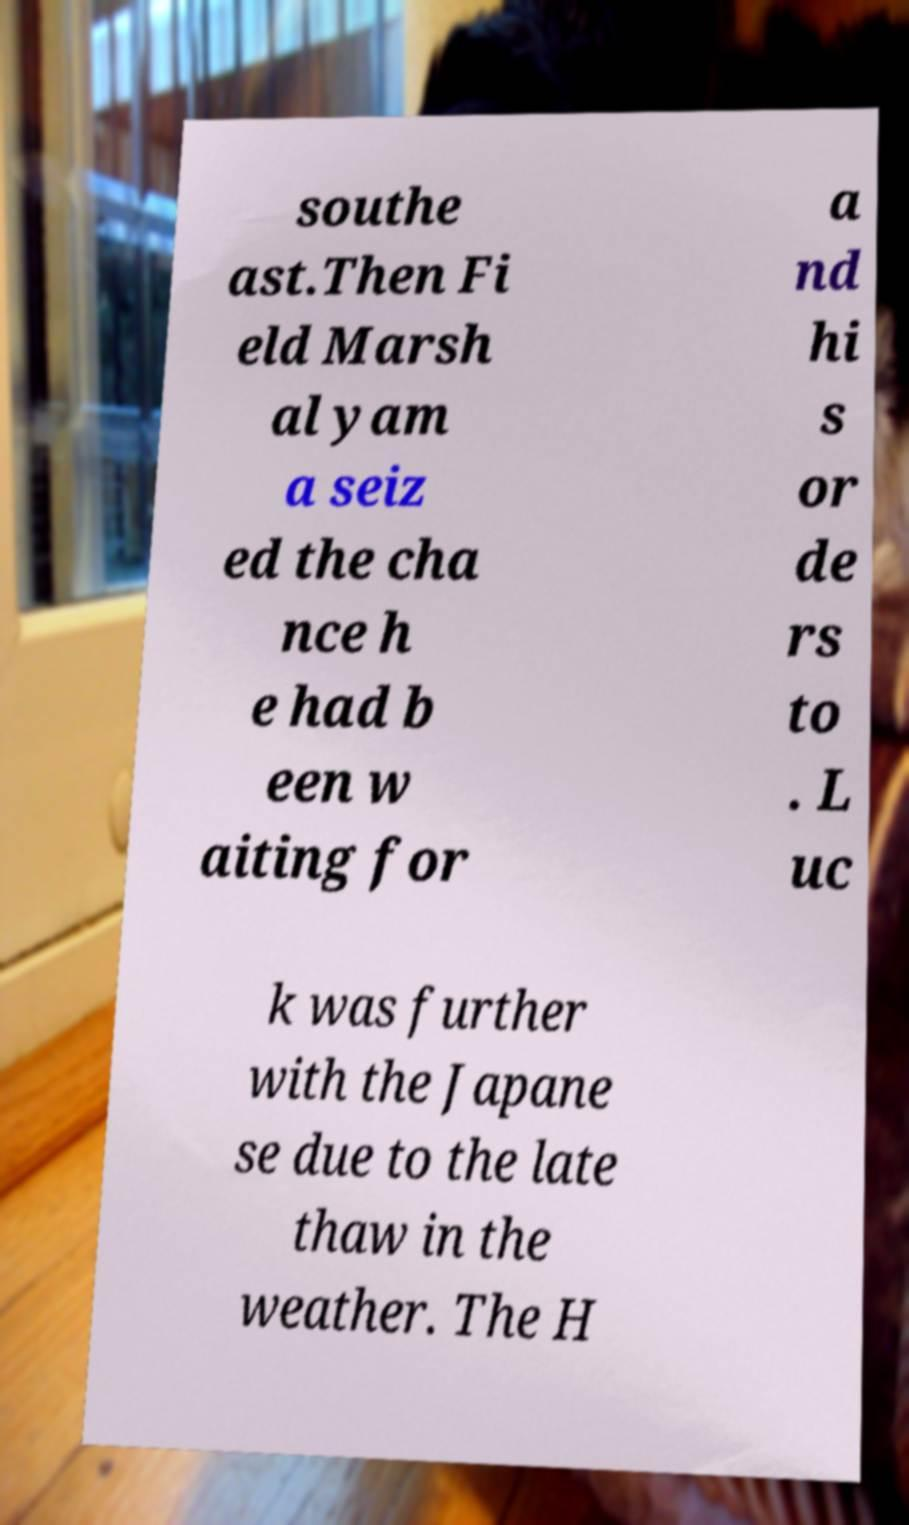Can you read and provide the text displayed in the image?This photo seems to have some interesting text. Can you extract and type it out for me? southe ast.Then Fi eld Marsh al yam a seiz ed the cha nce h e had b een w aiting for a nd hi s or de rs to . L uc k was further with the Japane se due to the late thaw in the weather. The H 